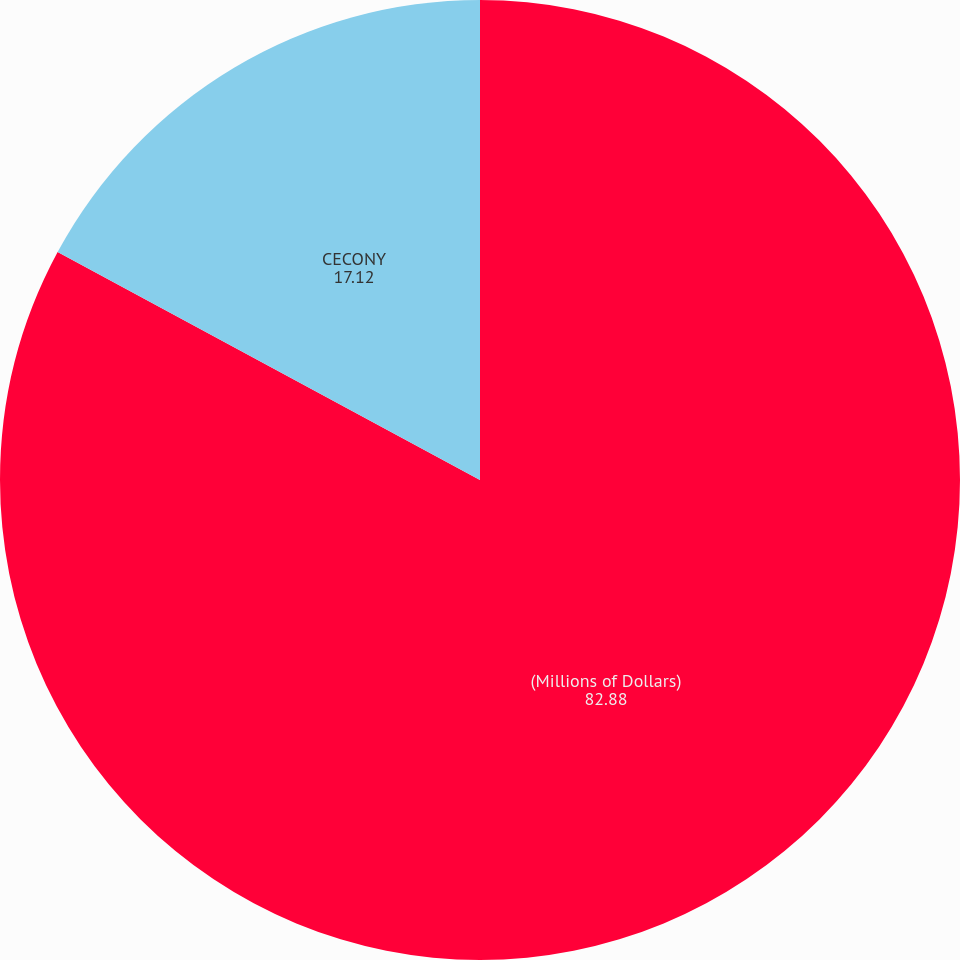Convert chart. <chart><loc_0><loc_0><loc_500><loc_500><pie_chart><fcel>(Millions of Dollars)<fcel>CECONY<nl><fcel>82.88%<fcel>17.12%<nl></chart> 